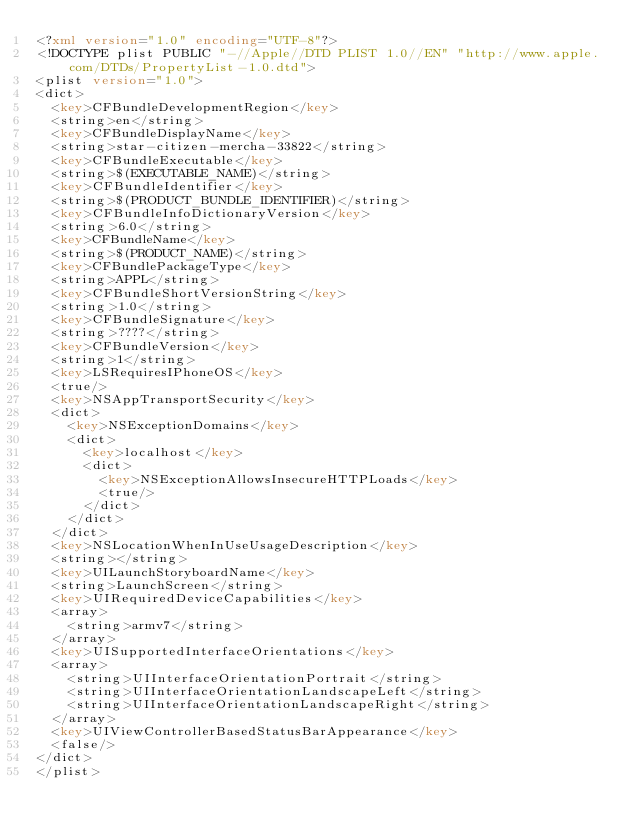Convert code to text. <code><loc_0><loc_0><loc_500><loc_500><_XML_><?xml version="1.0" encoding="UTF-8"?>
<!DOCTYPE plist PUBLIC "-//Apple//DTD PLIST 1.0//EN" "http://www.apple.com/DTDs/PropertyList-1.0.dtd">
<plist version="1.0">
<dict>
	<key>CFBundleDevelopmentRegion</key>
	<string>en</string>
	<key>CFBundleDisplayName</key>
	<string>star-citizen-mercha-33822</string>
	<key>CFBundleExecutable</key>
	<string>$(EXECUTABLE_NAME)</string>
	<key>CFBundleIdentifier</key>
	<string>$(PRODUCT_BUNDLE_IDENTIFIER)</string>
	<key>CFBundleInfoDictionaryVersion</key>
	<string>6.0</string>
	<key>CFBundleName</key>
	<string>$(PRODUCT_NAME)</string>
	<key>CFBundlePackageType</key>
	<string>APPL</string>
	<key>CFBundleShortVersionString</key>
	<string>1.0</string>
	<key>CFBundleSignature</key>
	<string>????</string>
	<key>CFBundleVersion</key>
	<string>1</string>
	<key>LSRequiresIPhoneOS</key>
	<true/>
	<key>NSAppTransportSecurity</key>
	<dict>
		<key>NSExceptionDomains</key>
		<dict>
			<key>localhost</key>
			<dict>
				<key>NSExceptionAllowsInsecureHTTPLoads</key>
				<true/>
			</dict>
		</dict>
	</dict>
	<key>NSLocationWhenInUseUsageDescription</key>
	<string></string>
	<key>UILaunchStoryboardName</key>
	<string>LaunchScreen</string>
	<key>UIRequiredDeviceCapabilities</key>
	<array>
		<string>armv7</string>
	</array>
	<key>UISupportedInterfaceOrientations</key>
	<array>
		<string>UIInterfaceOrientationPortrait</string>
		<string>UIInterfaceOrientationLandscapeLeft</string>
		<string>UIInterfaceOrientationLandscapeRight</string>
	</array>
	<key>UIViewControllerBasedStatusBarAppearance</key>
	<false/>
</dict>
</plist>
</code> 